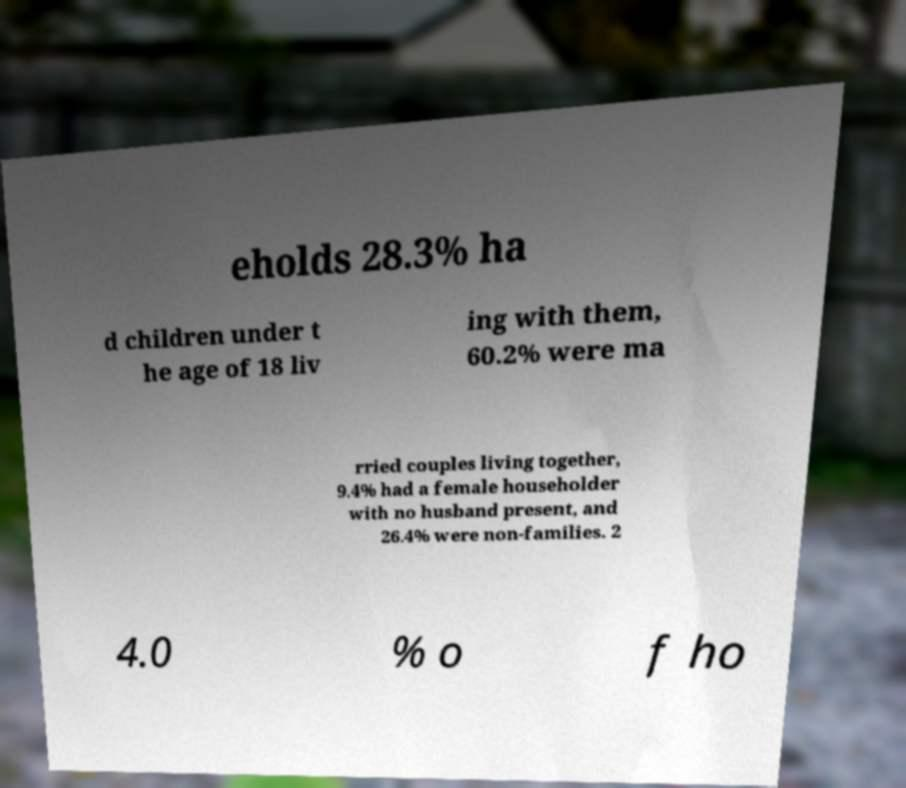I need the written content from this picture converted into text. Can you do that? eholds 28.3% ha d children under t he age of 18 liv ing with them, 60.2% were ma rried couples living together, 9.4% had a female householder with no husband present, and 26.4% were non-families. 2 4.0 % o f ho 